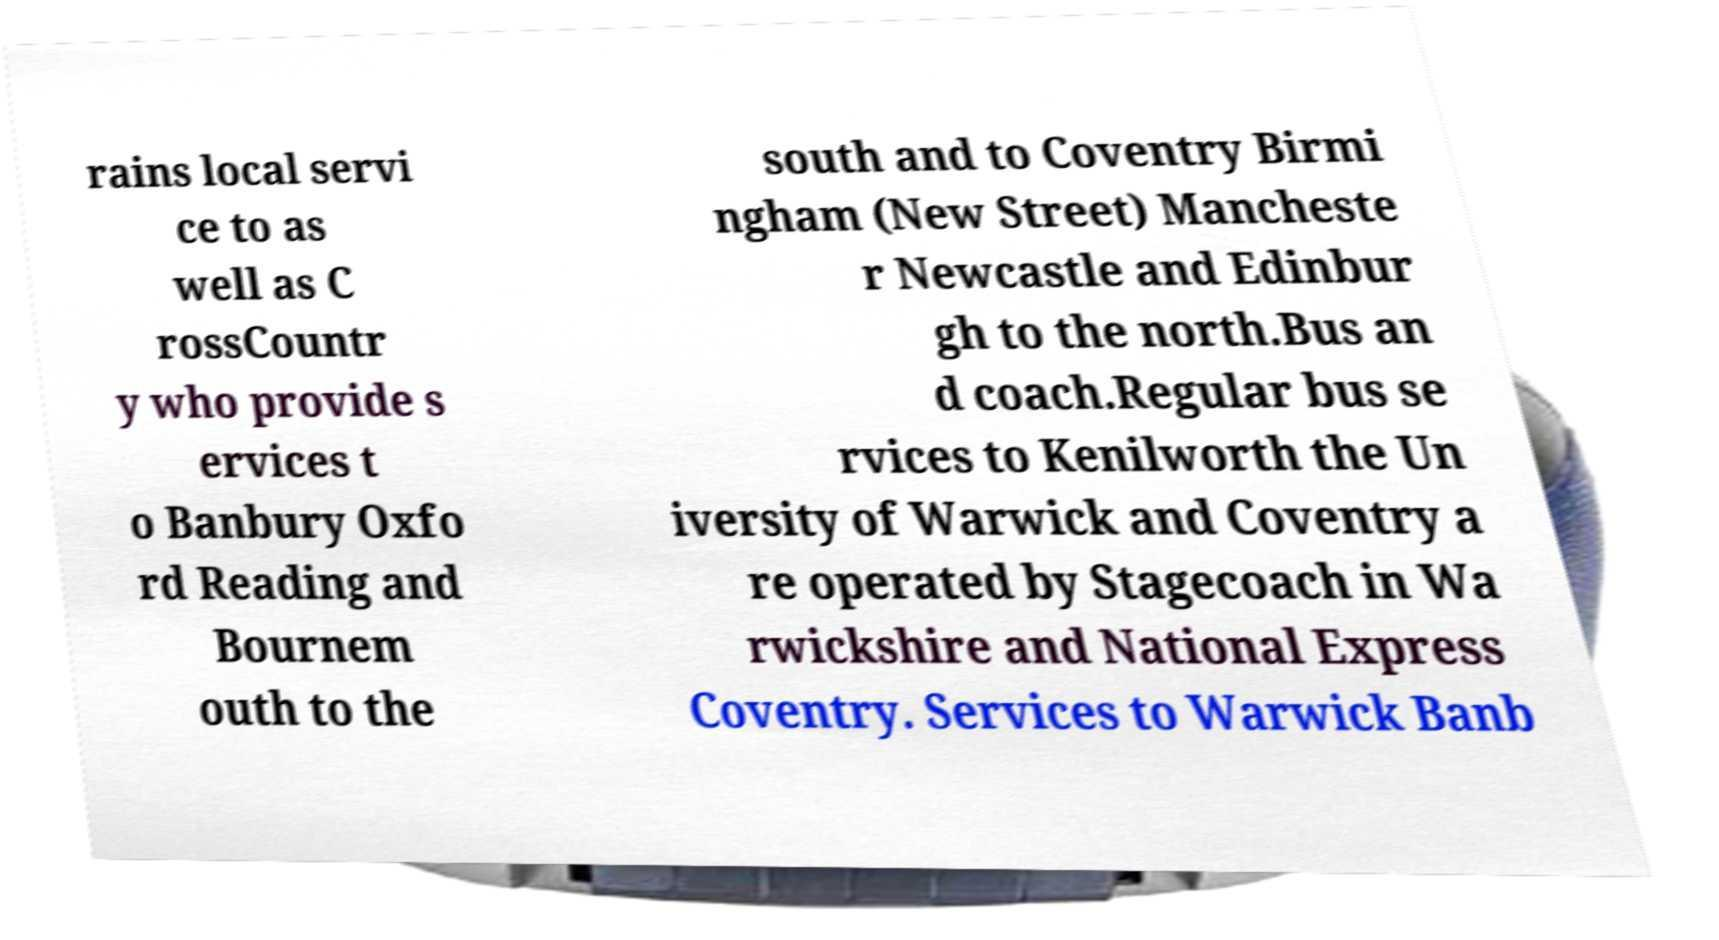There's text embedded in this image that I need extracted. Can you transcribe it verbatim? rains local servi ce to as well as C rossCountr y who provide s ervices t o Banbury Oxfo rd Reading and Bournem outh to the south and to Coventry Birmi ngham (New Street) Mancheste r Newcastle and Edinbur gh to the north.Bus an d coach.Regular bus se rvices to Kenilworth the Un iversity of Warwick and Coventry a re operated by Stagecoach in Wa rwickshire and National Express Coventry. Services to Warwick Banb 